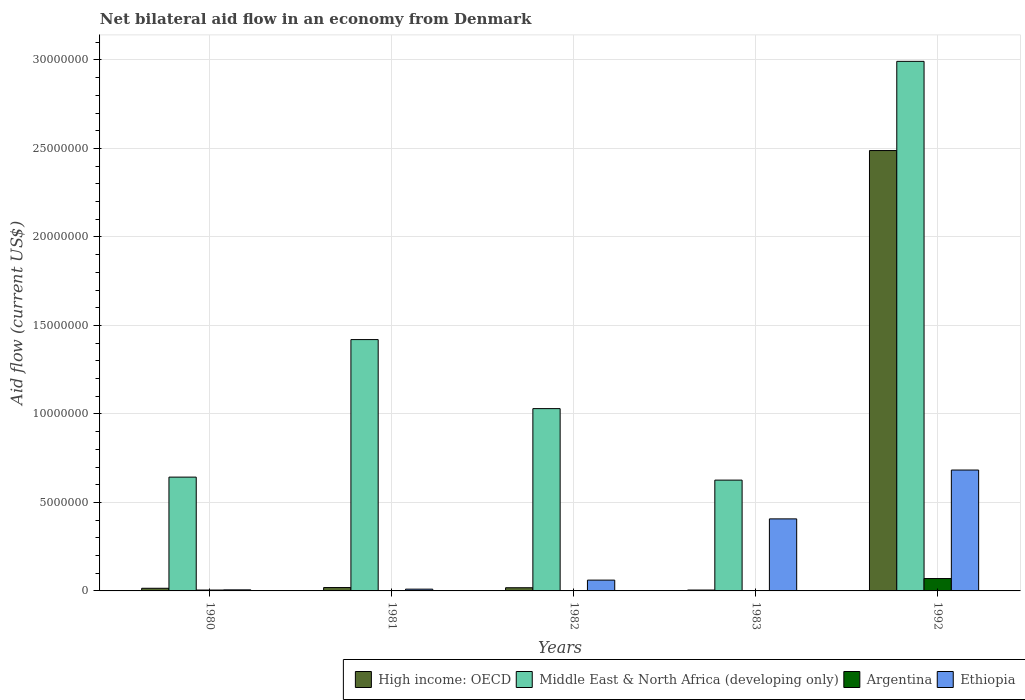How many different coloured bars are there?
Make the answer very short. 4. How many bars are there on the 5th tick from the right?
Ensure brevity in your answer.  4. What is the label of the 1st group of bars from the left?
Your answer should be very brief. 1980. In how many cases, is the number of bars for a given year not equal to the number of legend labels?
Your answer should be very brief. 0. What is the net bilateral aid flow in Argentina in 1981?
Provide a succinct answer. 2.00e+04. Across all years, what is the minimum net bilateral aid flow in Middle East & North Africa (developing only)?
Your answer should be very brief. 6.26e+06. In which year was the net bilateral aid flow in High income: OECD maximum?
Your response must be concise. 1992. In which year was the net bilateral aid flow in Ethiopia minimum?
Your response must be concise. 1980. What is the total net bilateral aid flow in Middle East & North Africa (developing only) in the graph?
Offer a terse response. 6.71e+07. What is the difference between the net bilateral aid flow in High income: OECD in 1980 and that in 1992?
Your answer should be compact. -2.47e+07. What is the difference between the net bilateral aid flow in High income: OECD in 1981 and the net bilateral aid flow in Ethiopia in 1982?
Your answer should be compact. -4.20e+05. What is the average net bilateral aid flow in Middle East & North Africa (developing only) per year?
Your response must be concise. 1.34e+07. In the year 1982, what is the difference between the net bilateral aid flow in Middle East & North Africa (developing only) and net bilateral aid flow in Argentina?
Give a very brief answer. 1.03e+07. What is the ratio of the net bilateral aid flow in High income: OECD in 1980 to that in 1982?
Your answer should be very brief. 0.83. Is the difference between the net bilateral aid flow in Middle East & North Africa (developing only) in 1980 and 1992 greater than the difference between the net bilateral aid flow in Argentina in 1980 and 1992?
Give a very brief answer. No. What is the difference between the highest and the second highest net bilateral aid flow in Middle East & North Africa (developing only)?
Make the answer very short. 1.57e+07. What is the difference between the highest and the lowest net bilateral aid flow in Ethiopia?
Offer a very short reply. 6.77e+06. What does the 2nd bar from the left in 1992 represents?
Give a very brief answer. Middle East & North Africa (developing only). What does the 4th bar from the right in 1980 represents?
Give a very brief answer. High income: OECD. How many bars are there?
Keep it short and to the point. 20. Are all the bars in the graph horizontal?
Provide a short and direct response. No. Does the graph contain any zero values?
Offer a very short reply. No. Does the graph contain grids?
Your response must be concise. Yes. Where does the legend appear in the graph?
Offer a terse response. Bottom right. How are the legend labels stacked?
Ensure brevity in your answer.  Horizontal. What is the title of the graph?
Your response must be concise. Net bilateral aid flow in an economy from Denmark. Does "Bahamas" appear as one of the legend labels in the graph?
Provide a succinct answer. No. What is the Aid flow (current US$) of Middle East & North Africa (developing only) in 1980?
Offer a very short reply. 6.43e+06. What is the Aid flow (current US$) in Argentina in 1980?
Offer a very short reply. 5.00e+04. What is the Aid flow (current US$) of High income: OECD in 1981?
Ensure brevity in your answer.  1.90e+05. What is the Aid flow (current US$) in Middle East & North Africa (developing only) in 1981?
Your response must be concise. 1.42e+07. What is the Aid flow (current US$) in Argentina in 1981?
Offer a terse response. 2.00e+04. What is the Aid flow (current US$) of High income: OECD in 1982?
Offer a terse response. 1.80e+05. What is the Aid flow (current US$) in Middle East & North Africa (developing only) in 1982?
Your response must be concise. 1.03e+07. What is the Aid flow (current US$) in Argentina in 1982?
Your response must be concise. 10000. What is the Aid flow (current US$) in Middle East & North Africa (developing only) in 1983?
Provide a short and direct response. 6.26e+06. What is the Aid flow (current US$) of Argentina in 1983?
Your response must be concise. 10000. What is the Aid flow (current US$) in Ethiopia in 1983?
Give a very brief answer. 4.07e+06. What is the Aid flow (current US$) of High income: OECD in 1992?
Make the answer very short. 2.49e+07. What is the Aid flow (current US$) in Middle East & North Africa (developing only) in 1992?
Offer a very short reply. 2.99e+07. What is the Aid flow (current US$) in Argentina in 1992?
Provide a short and direct response. 7.00e+05. What is the Aid flow (current US$) in Ethiopia in 1992?
Offer a terse response. 6.83e+06. Across all years, what is the maximum Aid flow (current US$) of High income: OECD?
Give a very brief answer. 2.49e+07. Across all years, what is the maximum Aid flow (current US$) of Middle East & North Africa (developing only)?
Offer a terse response. 2.99e+07. Across all years, what is the maximum Aid flow (current US$) of Ethiopia?
Your answer should be very brief. 6.83e+06. Across all years, what is the minimum Aid flow (current US$) in Middle East & North Africa (developing only)?
Give a very brief answer. 6.26e+06. Across all years, what is the minimum Aid flow (current US$) in Argentina?
Give a very brief answer. 10000. What is the total Aid flow (current US$) in High income: OECD in the graph?
Offer a terse response. 2.54e+07. What is the total Aid flow (current US$) in Middle East & North Africa (developing only) in the graph?
Ensure brevity in your answer.  6.71e+07. What is the total Aid flow (current US$) in Argentina in the graph?
Your answer should be compact. 7.90e+05. What is the total Aid flow (current US$) of Ethiopia in the graph?
Offer a very short reply. 1.17e+07. What is the difference between the Aid flow (current US$) of High income: OECD in 1980 and that in 1981?
Ensure brevity in your answer.  -4.00e+04. What is the difference between the Aid flow (current US$) in Middle East & North Africa (developing only) in 1980 and that in 1981?
Offer a terse response. -7.77e+06. What is the difference between the Aid flow (current US$) of Argentina in 1980 and that in 1981?
Your answer should be very brief. 3.00e+04. What is the difference between the Aid flow (current US$) of Ethiopia in 1980 and that in 1981?
Offer a terse response. -4.00e+04. What is the difference between the Aid flow (current US$) of Middle East & North Africa (developing only) in 1980 and that in 1982?
Your answer should be very brief. -3.87e+06. What is the difference between the Aid flow (current US$) of Argentina in 1980 and that in 1982?
Offer a very short reply. 4.00e+04. What is the difference between the Aid flow (current US$) in Ethiopia in 1980 and that in 1982?
Offer a terse response. -5.50e+05. What is the difference between the Aid flow (current US$) in Ethiopia in 1980 and that in 1983?
Your answer should be very brief. -4.01e+06. What is the difference between the Aid flow (current US$) of High income: OECD in 1980 and that in 1992?
Offer a very short reply. -2.47e+07. What is the difference between the Aid flow (current US$) of Middle East & North Africa (developing only) in 1980 and that in 1992?
Your answer should be compact. -2.35e+07. What is the difference between the Aid flow (current US$) of Argentina in 1980 and that in 1992?
Offer a very short reply. -6.50e+05. What is the difference between the Aid flow (current US$) of Ethiopia in 1980 and that in 1992?
Your response must be concise. -6.77e+06. What is the difference between the Aid flow (current US$) of High income: OECD in 1981 and that in 1982?
Offer a terse response. 10000. What is the difference between the Aid flow (current US$) in Middle East & North Africa (developing only) in 1981 and that in 1982?
Offer a terse response. 3.90e+06. What is the difference between the Aid flow (current US$) in Ethiopia in 1981 and that in 1982?
Your answer should be very brief. -5.10e+05. What is the difference between the Aid flow (current US$) of High income: OECD in 1981 and that in 1983?
Offer a very short reply. 1.40e+05. What is the difference between the Aid flow (current US$) in Middle East & North Africa (developing only) in 1981 and that in 1983?
Your answer should be very brief. 7.94e+06. What is the difference between the Aid flow (current US$) in Argentina in 1981 and that in 1983?
Provide a succinct answer. 10000. What is the difference between the Aid flow (current US$) in Ethiopia in 1981 and that in 1983?
Your answer should be compact. -3.97e+06. What is the difference between the Aid flow (current US$) of High income: OECD in 1981 and that in 1992?
Give a very brief answer. -2.47e+07. What is the difference between the Aid flow (current US$) in Middle East & North Africa (developing only) in 1981 and that in 1992?
Give a very brief answer. -1.57e+07. What is the difference between the Aid flow (current US$) of Argentina in 1981 and that in 1992?
Provide a succinct answer. -6.80e+05. What is the difference between the Aid flow (current US$) of Ethiopia in 1981 and that in 1992?
Give a very brief answer. -6.73e+06. What is the difference between the Aid flow (current US$) of Middle East & North Africa (developing only) in 1982 and that in 1983?
Keep it short and to the point. 4.04e+06. What is the difference between the Aid flow (current US$) in Argentina in 1982 and that in 1983?
Make the answer very short. 0. What is the difference between the Aid flow (current US$) of Ethiopia in 1982 and that in 1983?
Your answer should be very brief. -3.46e+06. What is the difference between the Aid flow (current US$) of High income: OECD in 1982 and that in 1992?
Offer a very short reply. -2.47e+07. What is the difference between the Aid flow (current US$) in Middle East & North Africa (developing only) in 1982 and that in 1992?
Make the answer very short. -1.96e+07. What is the difference between the Aid flow (current US$) of Argentina in 1982 and that in 1992?
Keep it short and to the point. -6.90e+05. What is the difference between the Aid flow (current US$) in Ethiopia in 1982 and that in 1992?
Provide a short and direct response. -6.22e+06. What is the difference between the Aid flow (current US$) of High income: OECD in 1983 and that in 1992?
Your answer should be compact. -2.48e+07. What is the difference between the Aid flow (current US$) in Middle East & North Africa (developing only) in 1983 and that in 1992?
Ensure brevity in your answer.  -2.37e+07. What is the difference between the Aid flow (current US$) in Argentina in 1983 and that in 1992?
Ensure brevity in your answer.  -6.90e+05. What is the difference between the Aid flow (current US$) of Ethiopia in 1983 and that in 1992?
Your response must be concise. -2.76e+06. What is the difference between the Aid flow (current US$) in High income: OECD in 1980 and the Aid flow (current US$) in Middle East & North Africa (developing only) in 1981?
Your answer should be very brief. -1.40e+07. What is the difference between the Aid flow (current US$) of High income: OECD in 1980 and the Aid flow (current US$) of Ethiopia in 1981?
Your answer should be very brief. 5.00e+04. What is the difference between the Aid flow (current US$) in Middle East & North Africa (developing only) in 1980 and the Aid flow (current US$) in Argentina in 1981?
Provide a succinct answer. 6.41e+06. What is the difference between the Aid flow (current US$) of Middle East & North Africa (developing only) in 1980 and the Aid flow (current US$) of Ethiopia in 1981?
Provide a succinct answer. 6.33e+06. What is the difference between the Aid flow (current US$) in High income: OECD in 1980 and the Aid flow (current US$) in Middle East & North Africa (developing only) in 1982?
Offer a very short reply. -1.02e+07. What is the difference between the Aid flow (current US$) of High income: OECD in 1980 and the Aid flow (current US$) of Ethiopia in 1982?
Offer a very short reply. -4.60e+05. What is the difference between the Aid flow (current US$) of Middle East & North Africa (developing only) in 1980 and the Aid flow (current US$) of Argentina in 1982?
Your response must be concise. 6.42e+06. What is the difference between the Aid flow (current US$) in Middle East & North Africa (developing only) in 1980 and the Aid flow (current US$) in Ethiopia in 1982?
Your answer should be compact. 5.82e+06. What is the difference between the Aid flow (current US$) of Argentina in 1980 and the Aid flow (current US$) of Ethiopia in 1982?
Give a very brief answer. -5.60e+05. What is the difference between the Aid flow (current US$) in High income: OECD in 1980 and the Aid flow (current US$) in Middle East & North Africa (developing only) in 1983?
Your answer should be compact. -6.11e+06. What is the difference between the Aid flow (current US$) in High income: OECD in 1980 and the Aid flow (current US$) in Argentina in 1983?
Ensure brevity in your answer.  1.40e+05. What is the difference between the Aid flow (current US$) in High income: OECD in 1980 and the Aid flow (current US$) in Ethiopia in 1983?
Provide a succinct answer. -3.92e+06. What is the difference between the Aid flow (current US$) in Middle East & North Africa (developing only) in 1980 and the Aid flow (current US$) in Argentina in 1983?
Ensure brevity in your answer.  6.42e+06. What is the difference between the Aid flow (current US$) of Middle East & North Africa (developing only) in 1980 and the Aid flow (current US$) of Ethiopia in 1983?
Keep it short and to the point. 2.36e+06. What is the difference between the Aid flow (current US$) of Argentina in 1980 and the Aid flow (current US$) of Ethiopia in 1983?
Your answer should be compact. -4.02e+06. What is the difference between the Aid flow (current US$) of High income: OECD in 1980 and the Aid flow (current US$) of Middle East & North Africa (developing only) in 1992?
Make the answer very short. -2.98e+07. What is the difference between the Aid flow (current US$) in High income: OECD in 1980 and the Aid flow (current US$) in Argentina in 1992?
Your answer should be compact. -5.50e+05. What is the difference between the Aid flow (current US$) of High income: OECD in 1980 and the Aid flow (current US$) of Ethiopia in 1992?
Make the answer very short. -6.68e+06. What is the difference between the Aid flow (current US$) of Middle East & North Africa (developing only) in 1980 and the Aid flow (current US$) of Argentina in 1992?
Provide a short and direct response. 5.73e+06. What is the difference between the Aid flow (current US$) in Middle East & North Africa (developing only) in 1980 and the Aid flow (current US$) in Ethiopia in 1992?
Offer a terse response. -4.00e+05. What is the difference between the Aid flow (current US$) in Argentina in 1980 and the Aid flow (current US$) in Ethiopia in 1992?
Provide a short and direct response. -6.78e+06. What is the difference between the Aid flow (current US$) in High income: OECD in 1981 and the Aid flow (current US$) in Middle East & North Africa (developing only) in 1982?
Your answer should be compact. -1.01e+07. What is the difference between the Aid flow (current US$) in High income: OECD in 1981 and the Aid flow (current US$) in Argentina in 1982?
Offer a terse response. 1.80e+05. What is the difference between the Aid flow (current US$) in High income: OECD in 1981 and the Aid flow (current US$) in Ethiopia in 1982?
Your response must be concise. -4.20e+05. What is the difference between the Aid flow (current US$) in Middle East & North Africa (developing only) in 1981 and the Aid flow (current US$) in Argentina in 1982?
Offer a terse response. 1.42e+07. What is the difference between the Aid flow (current US$) in Middle East & North Africa (developing only) in 1981 and the Aid flow (current US$) in Ethiopia in 1982?
Provide a succinct answer. 1.36e+07. What is the difference between the Aid flow (current US$) of Argentina in 1981 and the Aid flow (current US$) of Ethiopia in 1982?
Offer a very short reply. -5.90e+05. What is the difference between the Aid flow (current US$) in High income: OECD in 1981 and the Aid flow (current US$) in Middle East & North Africa (developing only) in 1983?
Ensure brevity in your answer.  -6.07e+06. What is the difference between the Aid flow (current US$) in High income: OECD in 1981 and the Aid flow (current US$) in Ethiopia in 1983?
Provide a succinct answer. -3.88e+06. What is the difference between the Aid flow (current US$) of Middle East & North Africa (developing only) in 1981 and the Aid flow (current US$) of Argentina in 1983?
Provide a short and direct response. 1.42e+07. What is the difference between the Aid flow (current US$) in Middle East & North Africa (developing only) in 1981 and the Aid flow (current US$) in Ethiopia in 1983?
Your response must be concise. 1.01e+07. What is the difference between the Aid flow (current US$) of Argentina in 1981 and the Aid flow (current US$) of Ethiopia in 1983?
Offer a terse response. -4.05e+06. What is the difference between the Aid flow (current US$) in High income: OECD in 1981 and the Aid flow (current US$) in Middle East & North Africa (developing only) in 1992?
Ensure brevity in your answer.  -2.97e+07. What is the difference between the Aid flow (current US$) in High income: OECD in 1981 and the Aid flow (current US$) in Argentina in 1992?
Offer a terse response. -5.10e+05. What is the difference between the Aid flow (current US$) in High income: OECD in 1981 and the Aid flow (current US$) in Ethiopia in 1992?
Your answer should be compact. -6.64e+06. What is the difference between the Aid flow (current US$) in Middle East & North Africa (developing only) in 1981 and the Aid flow (current US$) in Argentina in 1992?
Offer a very short reply. 1.35e+07. What is the difference between the Aid flow (current US$) in Middle East & North Africa (developing only) in 1981 and the Aid flow (current US$) in Ethiopia in 1992?
Ensure brevity in your answer.  7.37e+06. What is the difference between the Aid flow (current US$) of Argentina in 1981 and the Aid flow (current US$) of Ethiopia in 1992?
Ensure brevity in your answer.  -6.81e+06. What is the difference between the Aid flow (current US$) in High income: OECD in 1982 and the Aid flow (current US$) in Middle East & North Africa (developing only) in 1983?
Ensure brevity in your answer.  -6.08e+06. What is the difference between the Aid flow (current US$) of High income: OECD in 1982 and the Aid flow (current US$) of Argentina in 1983?
Make the answer very short. 1.70e+05. What is the difference between the Aid flow (current US$) in High income: OECD in 1982 and the Aid flow (current US$) in Ethiopia in 1983?
Make the answer very short. -3.89e+06. What is the difference between the Aid flow (current US$) of Middle East & North Africa (developing only) in 1982 and the Aid flow (current US$) of Argentina in 1983?
Keep it short and to the point. 1.03e+07. What is the difference between the Aid flow (current US$) in Middle East & North Africa (developing only) in 1982 and the Aid flow (current US$) in Ethiopia in 1983?
Provide a short and direct response. 6.23e+06. What is the difference between the Aid flow (current US$) in Argentina in 1982 and the Aid flow (current US$) in Ethiopia in 1983?
Keep it short and to the point. -4.06e+06. What is the difference between the Aid flow (current US$) in High income: OECD in 1982 and the Aid flow (current US$) in Middle East & North Africa (developing only) in 1992?
Make the answer very short. -2.97e+07. What is the difference between the Aid flow (current US$) in High income: OECD in 1982 and the Aid flow (current US$) in Argentina in 1992?
Make the answer very short. -5.20e+05. What is the difference between the Aid flow (current US$) of High income: OECD in 1982 and the Aid flow (current US$) of Ethiopia in 1992?
Make the answer very short. -6.65e+06. What is the difference between the Aid flow (current US$) of Middle East & North Africa (developing only) in 1982 and the Aid flow (current US$) of Argentina in 1992?
Provide a succinct answer. 9.60e+06. What is the difference between the Aid flow (current US$) in Middle East & North Africa (developing only) in 1982 and the Aid flow (current US$) in Ethiopia in 1992?
Your answer should be compact. 3.47e+06. What is the difference between the Aid flow (current US$) of Argentina in 1982 and the Aid flow (current US$) of Ethiopia in 1992?
Offer a very short reply. -6.82e+06. What is the difference between the Aid flow (current US$) of High income: OECD in 1983 and the Aid flow (current US$) of Middle East & North Africa (developing only) in 1992?
Your answer should be compact. -2.99e+07. What is the difference between the Aid flow (current US$) in High income: OECD in 1983 and the Aid flow (current US$) in Argentina in 1992?
Provide a short and direct response. -6.50e+05. What is the difference between the Aid flow (current US$) in High income: OECD in 1983 and the Aid flow (current US$) in Ethiopia in 1992?
Provide a short and direct response. -6.78e+06. What is the difference between the Aid flow (current US$) of Middle East & North Africa (developing only) in 1983 and the Aid flow (current US$) of Argentina in 1992?
Keep it short and to the point. 5.56e+06. What is the difference between the Aid flow (current US$) in Middle East & North Africa (developing only) in 1983 and the Aid flow (current US$) in Ethiopia in 1992?
Give a very brief answer. -5.70e+05. What is the difference between the Aid flow (current US$) in Argentina in 1983 and the Aid flow (current US$) in Ethiopia in 1992?
Give a very brief answer. -6.82e+06. What is the average Aid flow (current US$) in High income: OECD per year?
Keep it short and to the point. 5.09e+06. What is the average Aid flow (current US$) of Middle East & North Africa (developing only) per year?
Make the answer very short. 1.34e+07. What is the average Aid flow (current US$) in Argentina per year?
Provide a short and direct response. 1.58e+05. What is the average Aid flow (current US$) in Ethiopia per year?
Provide a succinct answer. 2.33e+06. In the year 1980, what is the difference between the Aid flow (current US$) in High income: OECD and Aid flow (current US$) in Middle East & North Africa (developing only)?
Keep it short and to the point. -6.28e+06. In the year 1980, what is the difference between the Aid flow (current US$) of High income: OECD and Aid flow (current US$) of Ethiopia?
Offer a very short reply. 9.00e+04. In the year 1980, what is the difference between the Aid flow (current US$) of Middle East & North Africa (developing only) and Aid flow (current US$) of Argentina?
Offer a very short reply. 6.38e+06. In the year 1980, what is the difference between the Aid flow (current US$) of Middle East & North Africa (developing only) and Aid flow (current US$) of Ethiopia?
Provide a succinct answer. 6.37e+06. In the year 1981, what is the difference between the Aid flow (current US$) of High income: OECD and Aid flow (current US$) of Middle East & North Africa (developing only)?
Provide a short and direct response. -1.40e+07. In the year 1981, what is the difference between the Aid flow (current US$) of High income: OECD and Aid flow (current US$) of Argentina?
Offer a very short reply. 1.70e+05. In the year 1981, what is the difference between the Aid flow (current US$) in High income: OECD and Aid flow (current US$) in Ethiopia?
Give a very brief answer. 9.00e+04. In the year 1981, what is the difference between the Aid flow (current US$) in Middle East & North Africa (developing only) and Aid flow (current US$) in Argentina?
Your response must be concise. 1.42e+07. In the year 1981, what is the difference between the Aid flow (current US$) in Middle East & North Africa (developing only) and Aid flow (current US$) in Ethiopia?
Make the answer very short. 1.41e+07. In the year 1981, what is the difference between the Aid flow (current US$) in Argentina and Aid flow (current US$) in Ethiopia?
Provide a succinct answer. -8.00e+04. In the year 1982, what is the difference between the Aid flow (current US$) in High income: OECD and Aid flow (current US$) in Middle East & North Africa (developing only)?
Ensure brevity in your answer.  -1.01e+07. In the year 1982, what is the difference between the Aid flow (current US$) in High income: OECD and Aid flow (current US$) in Argentina?
Your answer should be compact. 1.70e+05. In the year 1982, what is the difference between the Aid flow (current US$) of High income: OECD and Aid flow (current US$) of Ethiopia?
Make the answer very short. -4.30e+05. In the year 1982, what is the difference between the Aid flow (current US$) of Middle East & North Africa (developing only) and Aid flow (current US$) of Argentina?
Your answer should be compact. 1.03e+07. In the year 1982, what is the difference between the Aid flow (current US$) of Middle East & North Africa (developing only) and Aid flow (current US$) of Ethiopia?
Your response must be concise. 9.69e+06. In the year 1982, what is the difference between the Aid flow (current US$) of Argentina and Aid flow (current US$) of Ethiopia?
Ensure brevity in your answer.  -6.00e+05. In the year 1983, what is the difference between the Aid flow (current US$) of High income: OECD and Aid flow (current US$) of Middle East & North Africa (developing only)?
Give a very brief answer. -6.21e+06. In the year 1983, what is the difference between the Aid flow (current US$) in High income: OECD and Aid flow (current US$) in Argentina?
Provide a succinct answer. 4.00e+04. In the year 1983, what is the difference between the Aid flow (current US$) of High income: OECD and Aid flow (current US$) of Ethiopia?
Give a very brief answer. -4.02e+06. In the year 1983, what is the difference between the Aid flow (current US$) in Middle East & North Africa (developing only) and Aid flow (current US$) in Argentina?
Keep it short and to the point. 6.25e+06. In the year 1983, what is the difference between the Aid flow (current US$) in Middle East & North Africa (developing only) and Aid flow (current US$) in Ethiopia?
Give a very brief answer. 2.19e+06. In the year 1983, what is the difference between the Aid flow (current US$) in Argentina and Aid flow (current US$) in Ethiopia?
Your answer should be very brief. -4.06e+06. In the year 1992, what is the difference between the Aid flow (current US$) of High income: OECD and Aid flow (current US$) of Middle East & North Africa (developing only)?
Make the answer very short. -5.04e+06. In the year 1992, what is the difference between the Aid flow (current US$) of High income: OECD and Aid flow (current US$) of Argentina?
Provide a short and direct response. 2.42e+07. In the year 1992, what is the difference between the Aid flow (current US$) in High income: OECD and Aid flow (current US$) in Ethiopia?
Your response must be concise. 1.80e+07. In the year 1992, what is the difference between the Aid flow (current US$) in Middle East & North Africa (developing only) and Aid flow (current US$) in Argentina?
Ensure brevity in your answer.  2.92e+07. In the year 1992, what is the difference between the Aid flow (current US$) of Middle East & North Africa (developing only) and Aid flow (current US$) of Ethiopia?
Offer a very short reply. 2.31e+07. In the year 1992, what is the difference between the Aid flow (current US$) of Argentina and Aid flow (current US$) of Ethiopia?
Your answer should be compact. -6.13e+06. What is the ratio of the Aid flow (current US$) of High income: OECD in 1980 to that in 1981?
Provide a short and direct response. 0.79. What is the ratio of the Aid flow (current US$) in Middle East & North Africa (developing only) in 1980 to that in 1981?
Provide a short and direct response. 0.45. What is the ratio of the Aid flow (current US$) of Argentina in 1980 to that in 1981?
Offer a very short reply. 2.5. What is the ratio of the Aid flow (current US$) in High income: OECD in 1980 to that in 1982?
Provide a short and direct response. 0.83. What is the ratio of the Aid flow (current US$) of Middle East & North Africa (developing only) in 1980 to that in 1982?
Your answer should be very brief. 0.62. What is the ratio of the Aid flow (current US$) of Ethiopia in 1980 to that in 1982?
Your answer should be very brief. 0.1. What is the ratio of the Aid flow (current US$) in High income: OECD in 1980 to that in 1983?
Give a very brief answer. 3. What is the ratio of the Aid flow (current US$) in Middle East & North Africa (developing only) in 1980 to that in 1983?
Your answer should be very brief. 1.03. What is the ratio of the Aid flow (current US$) in Argentina in 1980 to that in 1983?
Give a very brief answer. 5. What is the ratio of the Aid flow (current US$) in Ethiopia in 1980 to that in 1983?
Offer a terse response. 0.01. What is the ratio of the Aid flow (current US$) in High income: OECD in 1980 to that in 1992?
Provide a short and direct response. 0.01. What is the ratio of the Aid flow (current US$) of Middle East & North Africa (developing only) in 1980 to that in 1992?
Provide a short and direct response. 0.21. What is the ratio of the Aid flow (current US$) of Argentina in 1980 to that in 1992?
Provide a succinct answer. 0.07. What is the ratio of the Aid flow (current US$) in Ethiopia in 1980 to that in 1992?
Give a very brief answer. 0.01. What is the ratio of the Aid flow (current US$) in High income: OECD in 1981 to that in 1982?
Your response must be concise. 1.06. What is the ratio of the Aid flow (current US$) of Middle East & North Africa (developing only) in 1981 to that in 1982?
Make the answer very short. 1.38. What is the ratio of the Aid flow (current US$) in Argentina in 1981 to that in 1982?
Keep it short and to the point. 2. What is the ratio of the Aid flow (current US$) in Ethiopia in 1981 to that in 1982?
Offer a terse response. 0.16. What is the ratio of the Aid flow (current US$) of High income: OECD in 1981 to that in 1983?
Give a very brief answer. 3.8. What is the ratio of the Aid flow (current US$) in Middle East & North Africa (developing only) in 1981 to that in 1983?
Give a very brief answer. 2.27. What is the ratio of the Aid flow (current US$) of Ethiopia in 1981 to that in 1983?
Provide a short and direct response. 0.02. What is the ratio of the Aid flow (current US$) in High income: OECD in 1981 to that in 1992?
Provide a succinct answer. 0.01. What is the ratio of the Aid flow (current US$) in Middle East & North Africa (developing only) in 1981 to that in 1992?
Offer a very short reply. 0.47. What is the ratio of the Aid flow (current US$) in Argentina in 1981 to that in 1992?
Provide a succinct answer. 0.03. What is the ratio of the Aid flow (current US$) of Ethiopia in 1981 to that in 1992?
Your answer should be very brief. 0.01. What is the ratio of the Aid flow (current US$) in High income: OECD in 1982 to that in 1983?
Keep it short and to the point. 3.6. What is the ratio of the Aid flow (current US$) in Middle East & North Africa (developing only) in 1982 to that in 1983?
Make the answer very short. 1.65. What is the ratio of the Aid flow (current US$) in Ethiopia in 1982 to that in 1983?
Your response must be concise. 0.15. What is the ratio of the Aid flow (current US$) in High income: OECD in 1982 to that in 1992?
Provide a short and direct response. 0.01. What is the ratio of the Aid flow (current US$) of Middle East & North Africa (developing only) in 1982 to that in 1992?
Provide a succinct answer. 0.34. What is the ratio of the Aid flow (current US$) in Argentina in 1982 to that in 1992?
Keep it short and to the point. 0.01. What is the ratio of the Aid flow (current US$) in Ethiopia in 1982 to that in 1992?
Provide a short and direct response. 0.09. What is the ratio of the Aid flow (current US$) in High income: OECD in 1983 to that in 1992?
Provide a short and direct response. 0. What is the ratio of the Aid flow (current US$) in Middle East & North Africa (developing only) in 1983 to that in 1992?
Give a very brief answer. 0.21. What is the ratio of the Aid flow (current US$) of Argentina in 1983 to that in 1992?
Provide a short and direct response. 0.01. What is the ratio of the Aid flow (current US$) in Ethiopia in 1983 to that in 1992?
Your answer should be compact. 0.6. What is the difference between the highest and the second highest Aid flow (current US$) of High income: OECD?
Ensure brevity in your answer.  2.47e+07. What is the difference between the highest and the second highest Aid flow (current US$) of Middle East & North Africa (developing only)?
Keep it short and to the point. 1.57e+07. What is the difference between the highest and the second highest Aid flow (current US$) of Argentina?
Your answer should be very brief. 6.50e+05. What is the difference between the highest and the second highest Aid flow (current US$) in Ethiopia?
Your answer should be compact. 2.76e+06. What is the difference between the highest and the lowest Aid flow (current US$) of High income: OECD?
Make the answer very short. 2.48e+07. What is the difference between the highest and the lowest Aid flow (current US$) in Middle East & North Africa (developing only)?
Ensure brevity in your answer.  2.37e+07. What is the difference between the highest and the lowest Aid flow (current US$) in Argentina?
Provide a succinct answer. 6.90e+05. What is the difference between the highest and the lowest Aid flow (current US$) in Ethiopia?
Your answer should be compact. 6.77e+06. 